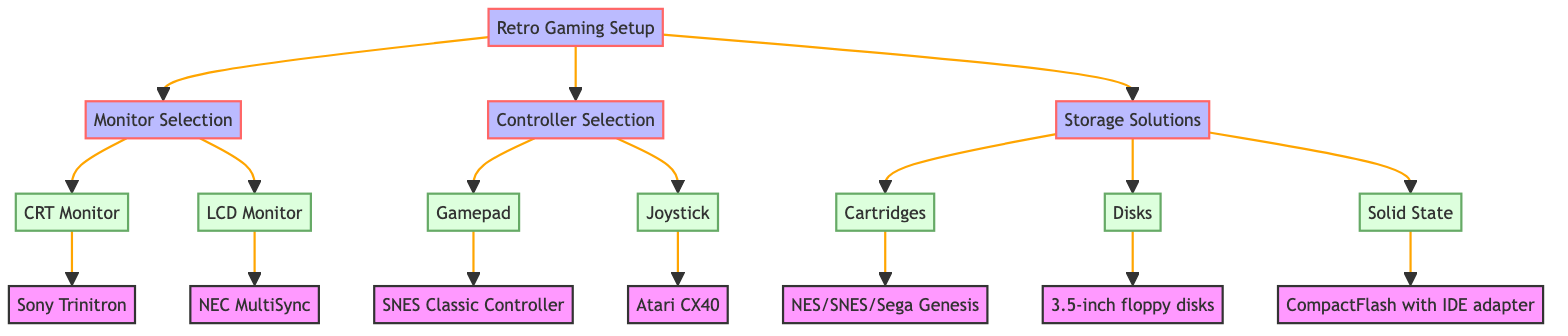What are the three main categories in the retro gaming setup? The diagram shows three main categories: Monitor Selection, Controller Selection, and Storage Solutions, branching out from the Retro Gaming Setup node.
Answer: Monitor Selection, Controller Selection, Storage Solutions Which monitor type is associated with older consoles? The CRT Monitor is listed under Monitor Selection, and its subcategory, Sony Trinitron, states compatibility with older consoles and DOS PCs.
Answer: CRT Monitor How many controller types are presented in the diagram? Under Controller Selection, there are two types indicated: Gamepad and Joystick. Thus, the total count is two.
Answer: 2 What storage solution type is compatible with MS-DOS PCs? The diagram illustrates that the Disks section includes 3.5-inch floppy disks, which list their compatibility with MS-DOS PCs.
Answer: Disks Which controller is designed for the SNES Console? The Gamepad section leads to SNES Classic Controller under Controller Selection, specifically indicating its compatibility with the SNES Console.
Answer: SNES Classic Controller What are the features shared by Cartridges as a storage solution? The Cartridges section mentions features such as Durability and Instant load times, which are both applicable to this type of storage solution.
Answer: Durability, Instant load times Which two monitor types are presented under Monitor Selection? The Monitor Selection node branches into two options: CRT Monitor and LCD Monitor, which represent the types available for selection.
Answer: CRT Monitor, LCD Monitor Which storage solution type offers high capacity and reliability? The Solid State section presents CompactFlash with IDE adapter and denotes features highlighting high capacity and reliability.
Answer: Solid State What is the compatibility of the Atari CX40? The Joystick subcategory leads to Atari CX40, which lists its compatibility with Atari 2600 and Commodore 64.
Answer: Atari 2600, Commodore 64 